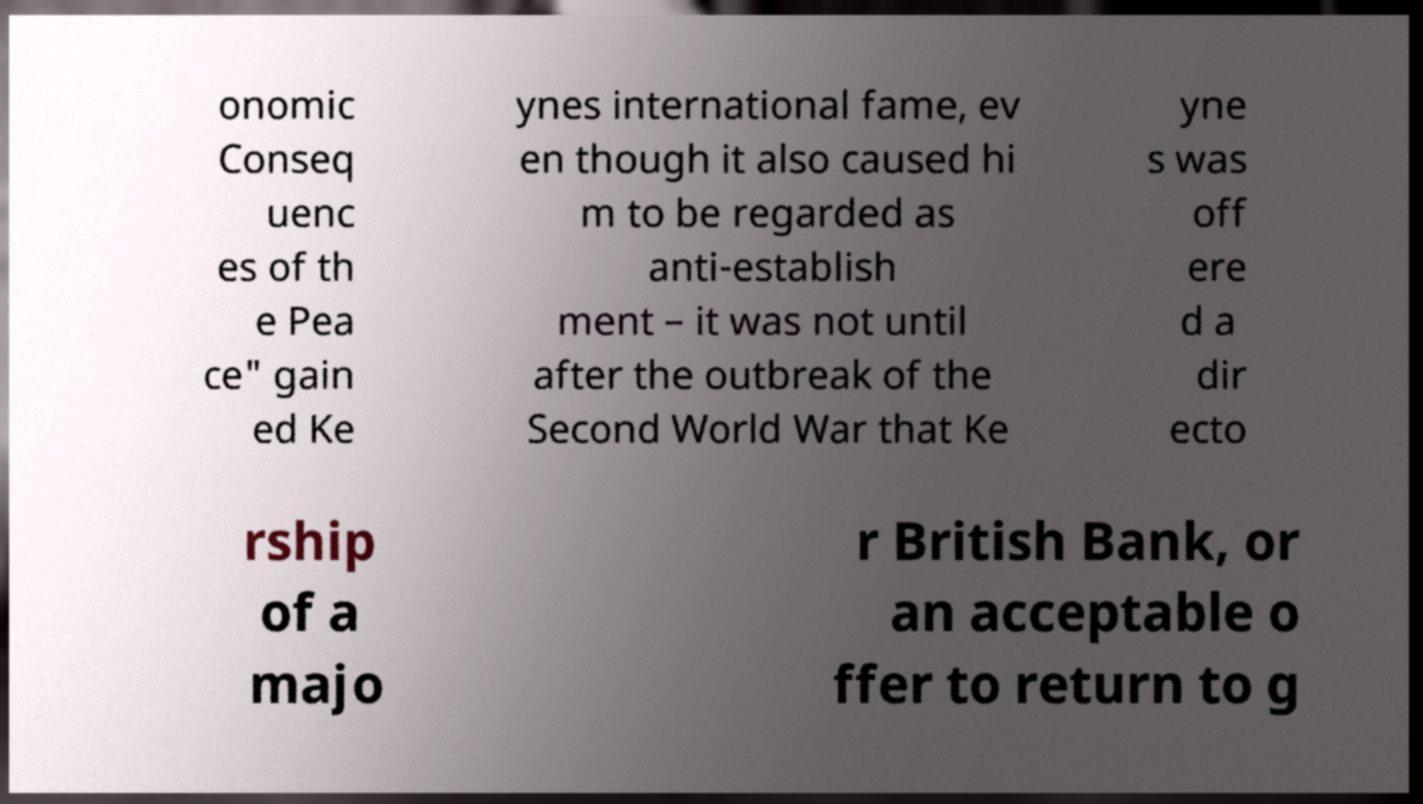Please read and relay the text visible in this image. What does it say? onomic Conseq uenc es of th e Pea ce" gain ed Ke ynes international fame, ev en though it also caused hi m to be regarded as anti-establish ment – it was not until after the outbreak of the Second World War that Ke yne s was off ere d a dir ecto rship of a majo r British Bank, or an acceptable o ffer to return to g 